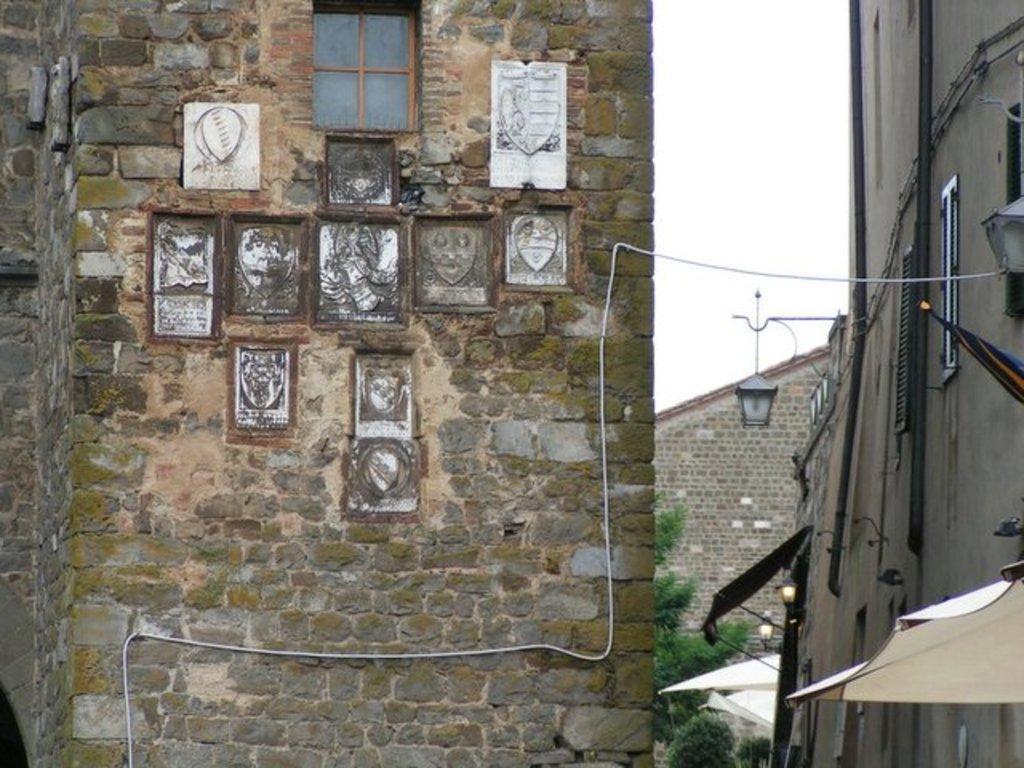Could you give a brief overview of what you see in this image? In this picture we can see boards on the wall, buildings with windows, lamps, sunshades, trees, some objects and in the background we can see the sky. 